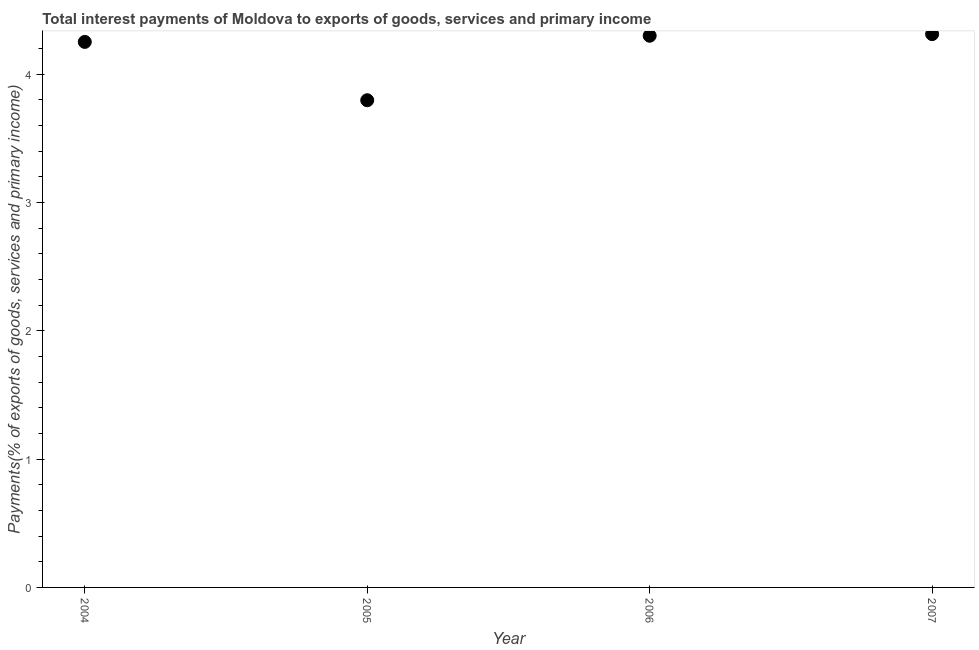What is the total interest payments on external debt in 2004?
Offer a terse response. 4.25. Across all years, what is the maximum total interest payments on external debt?
Make the answer very short. 4.31. Across all years, what is the minimum total interest payments on external debt?
Your answer should be very brief. 3.8. In which year was the total interest payments on external debt minimum?
Offer a terse response. 2005. What is the sum of the total interest payments on external debt?
Your answer should be compact. 16.66. What is the difference between the total interest payments on external debt in 2006 and 2007?
Give a very brief answer. -0.01. What is the average total interest payments on external debt per year?
Offer a very short reply. 4.16. What is the median total interest payments on external debt?
Your answer should be very brief. 4.27. What is the ratio of the total interest payments on external debt in 2004 to that in 2007?
Make the answer very short. 0.99. Is the difference between the total interest payments on external debt in 2004 and 2005 greater than the difference between any two years?
Provide a succinct answer. No. What is the difference between the highest and the second highest total interest payments on external debt?
Provide a succinct answer. 0.01. Is the sum of the total interest payments on external debt in 2004 and 2006 greater than the maximum total interest payments on external debt across all years?
Offer a very short reply. Yes. What is the difference between the highest and the lowest total interest payments on external debt?
Give a very brief answer. 0.52. Does the total interest payments on external debt monotonically increase over the years?
Your answer should be very brief. No. How many dotlines are there?
Provide a succinct answer. 1. What is the difference between two consecutive major ticks on the Y-axis?
Your answer should be compact. 1. Does the graph contain any zero values?
Your answer should be compact. No. What is the title of the graph?
Give a very brief answer. Total interest payments of Moldova to exports of goods, services and primary income. What is the label or title of the Y-axis?
Provide a succinct answer. Payments(% of exports of goods, services and primary income). What is the Payments(% of exports of goods, services and primary income) in 2004?
Ensure brevity in your answer.  4.25. What is the Payments(% of exports of goods, services and primary income) in 2005?
Keep it short and to the point. 3.8. What is the Payments(% of exports of goods, services and primary income) in 2006?
Make the answer very short. 4.3. What is the Payments(% of exports of goods, services and primary income) in 2007?
Your response must be concise. 4.31. What is the difference between the Payments(% of exports of goods, services and primary income) in 2004 and 2005?
Keep it short and to the point. 0.45. What is the difference between the Payments(% of exports of goods, services and primary income) in 2004 and 2006?
Provide a succinct answer. -0.05. What is the difference between the Payments(% of exports of goods, services and primary income) in 2004 and 2007?
Your answer should be compact. -0.06. What is the difference between the Payments(% of exports of goods, services and primary income) in 2005 and 2006?
Give a very brief answer. -0.5. What is the difference between the Payments(% of exports of goods, services and primary income) in 2005 and 2007?
Offer a terse response. -0.52. What is the difference between the Payments(% of exports of goods, services and primary income) in 2006 and 2007?
Offer a very short reply. -0.01. What is the ratio of the Payments(% of exports of goods, services and primary income) in 2004 to that in 2005?
Ensure brevity in your answer.  1.12. What is the ratio of the Payments(% of exports of goods, services and primary income) in 2004 to that in 2006?
Your answer should be compact. 0.99. What is the ratio of the Payments(% of exports of goods, services and primary income) in 2004 to that in 2007?
Your response must be concise. 0.99. What is the ratio of the Payments(% of exports of goods, services and primary income) in 2005 to that in 2006?
Give a very brief answer. 0.88. 